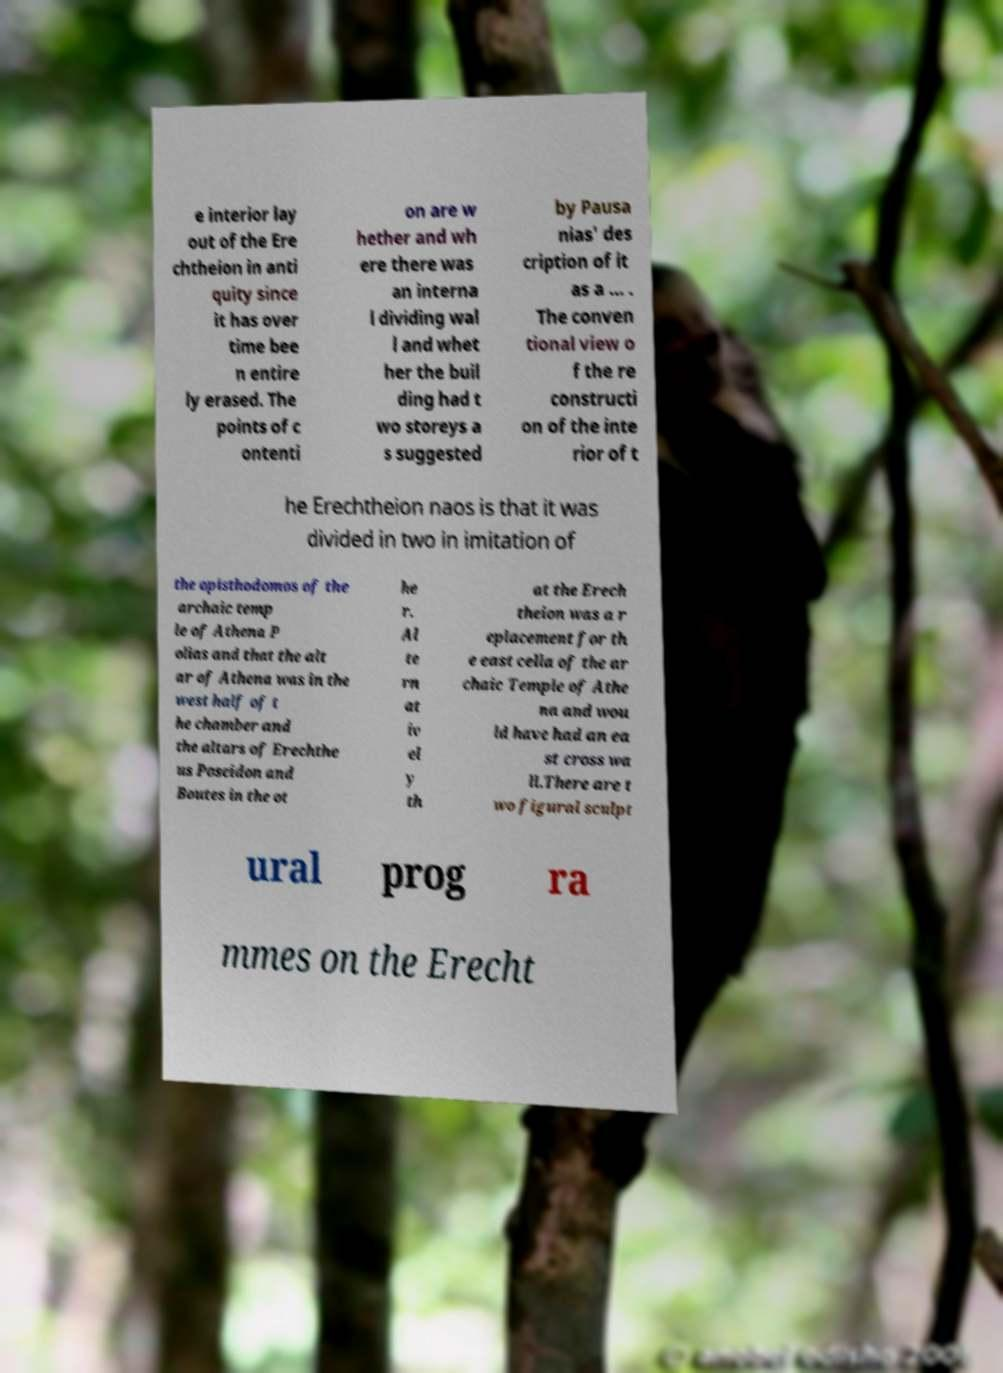What messages or text are displayed in this image? I need them in a readable, typed format. e interior lay out of the Ere chtheion in anti quity since it has over time bee n entire ly erased. The points of c ontenti on are w hether and wh ere there was an interna l dividing wal l and whet her the buil ding had t wo storeys a s suggested by Pausa nias' des cription of it as a ... . The conven tional view o f the re constructi on of the inte rior of t he Erechtheion naos is that it was divided in two in imitation of the opisthodomos of the archaic temp le of Athena P olias and that the alt ar of Athena was in the west half of t he chamber and the altars of Erechthe us Poseidon and Boutes in the ot he r. Al te rn at iv el y th at the Erech theion was a r eplacement for th e east cella of the ar chaic Temple of Athe na and wou ld have had an ea st cross wa ll.There are t wo figural sculpt ural prog ra mmes on the Erecht 